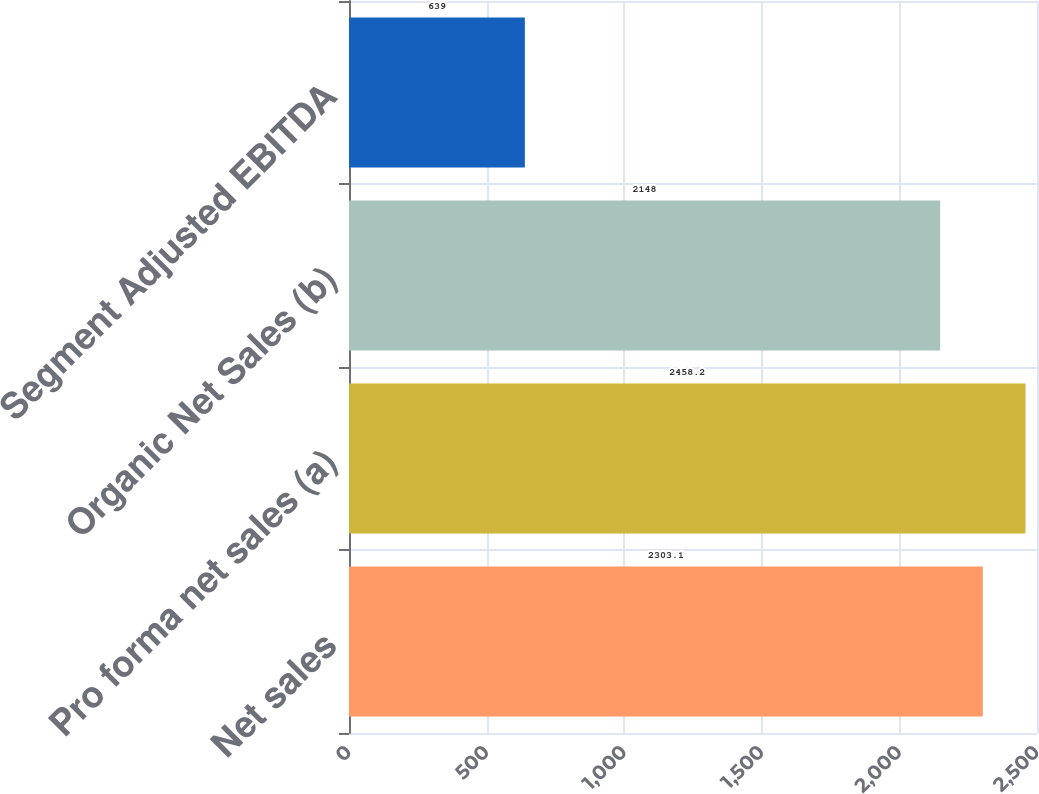Convert chart. <chart><loc_0><loc_0><loc_500><loc_500><bar_chart><fcel>Net sales<fcel>Pro forma net sales (a)<fcel>Organic Net Sales (b)<fcel>Segment Adjusted EBITDA<nl><fcel>2303.1<fcel>2458.2<fcel>2148<fcel>639<nl></chart> 